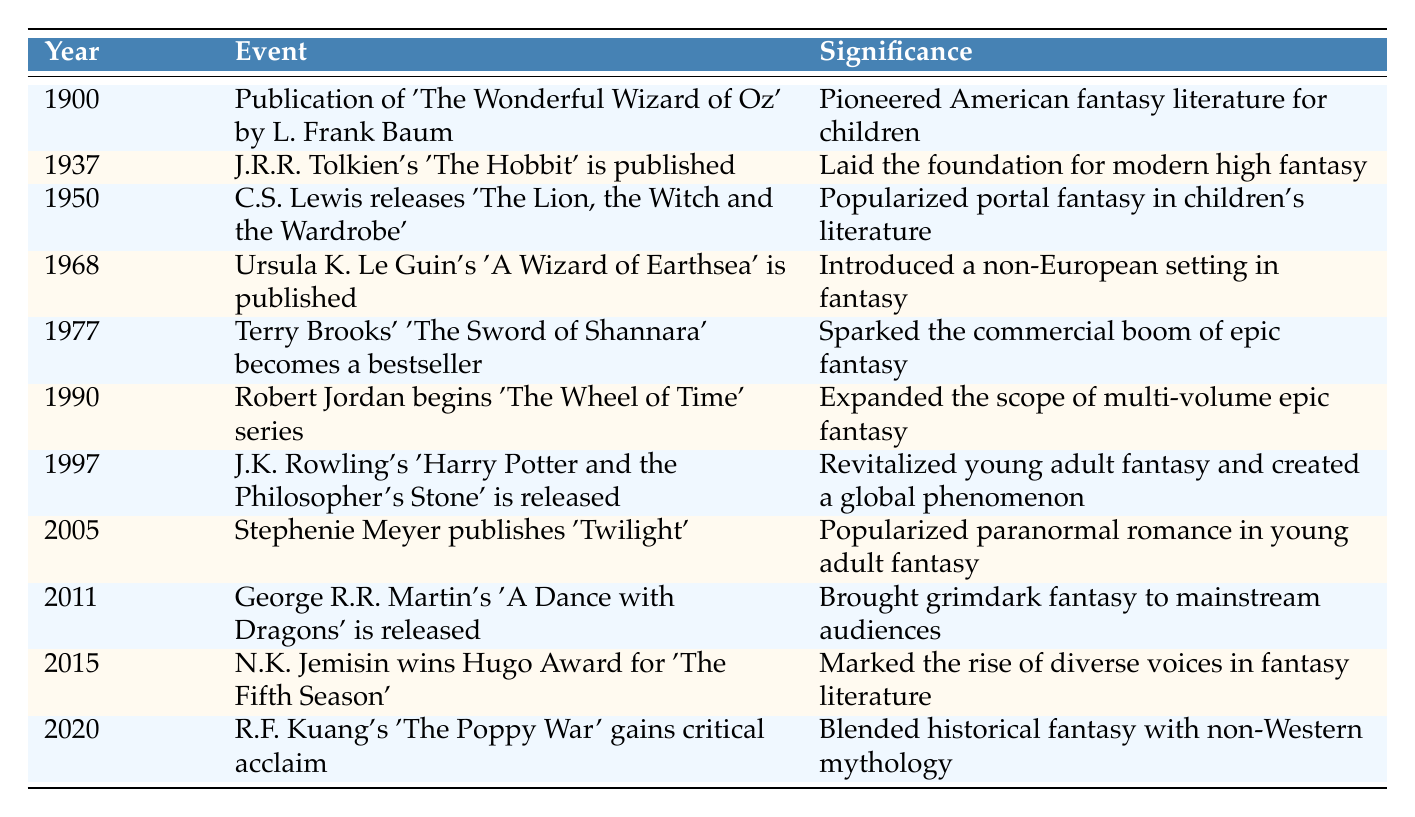What year was 'The Lion, the Witch and the Wardrobe' published? The table states that C.S. Lewis' 'The Lion, the Witch and the Wardrobe' was published in 1950.
Answer: 1950 Which book is credited with laying the foundation for modern high fantasy? According to the table, J.R.R. Tolkien's 'The Hobbit', published in 1937, is credited with laying this foundation.
Answer: 'The Hobbit' Was 'Twilight' published before or after 'Harry Potter and the Philosopher's Stone'? The table shows 'Harry Potter and the Philosopher's Stone' was released in 1997, while 'Twilight' was published in 2005, which means 'Twilight' was published after.
Answer: After What is the significance of 'The Poppy War'? The table states that 'The Poppy War' by R.F. Kuang, published in 2020, is significant for blending historical fantasy with non-Western mythology.
Answer: Blended historical fantasy with non-Western mythology How many years passed between the publication of 'The Hobbit' and 'A Dance with Dragons'? 'The Hobbit' was published in 1937 and 'A Dance with Dragons' in 2011. The difference in years is 2011 - 1937 = 74 years.
Answer: 74 years Which author introduced a non-European setting in fantasy? The table indicates that Ursula K. Le Guin introduced a non-European setting with 'A Wizard of Earthsea' published in 1968.
Answer: Ursula K. Le Guin Did any of the authors listed win a major literary award? Yes, the table states that N.K. Jemisin won the Hugo Award for 'The Fifth Season' in 2015, indicating that at least one author won a major literary award.
Answer: Yes What trend can be observed from the table regarding the diversity of voices in fantasy literature over time? The timeline shows that earlier publications focused mainly on Western narratives, while later works, particularly starting from 2015, emphasize diverse voices, as highlighted by N.K. Jemisin's win and R.F. Kuang's work. This indicates a shift towards inclusivity in fantasy literature.
Answer: Increased diversity since 2015 Which event marked the commercial boom of epic fantasy? The table states that the publication of Terry Brooks' 'The Sword of Shannara' in 1977 sparked the commercial boom of epic fantasy.
Answer: 'The Sword of Shannara' in 1977 What year signifies the rise of diverse voices in fantasy literature? The timeline indicates that the year 2015 is significant for the rise of diverse voices, particularly with N.K. Jemisin's recognition.
Answer: 2015 